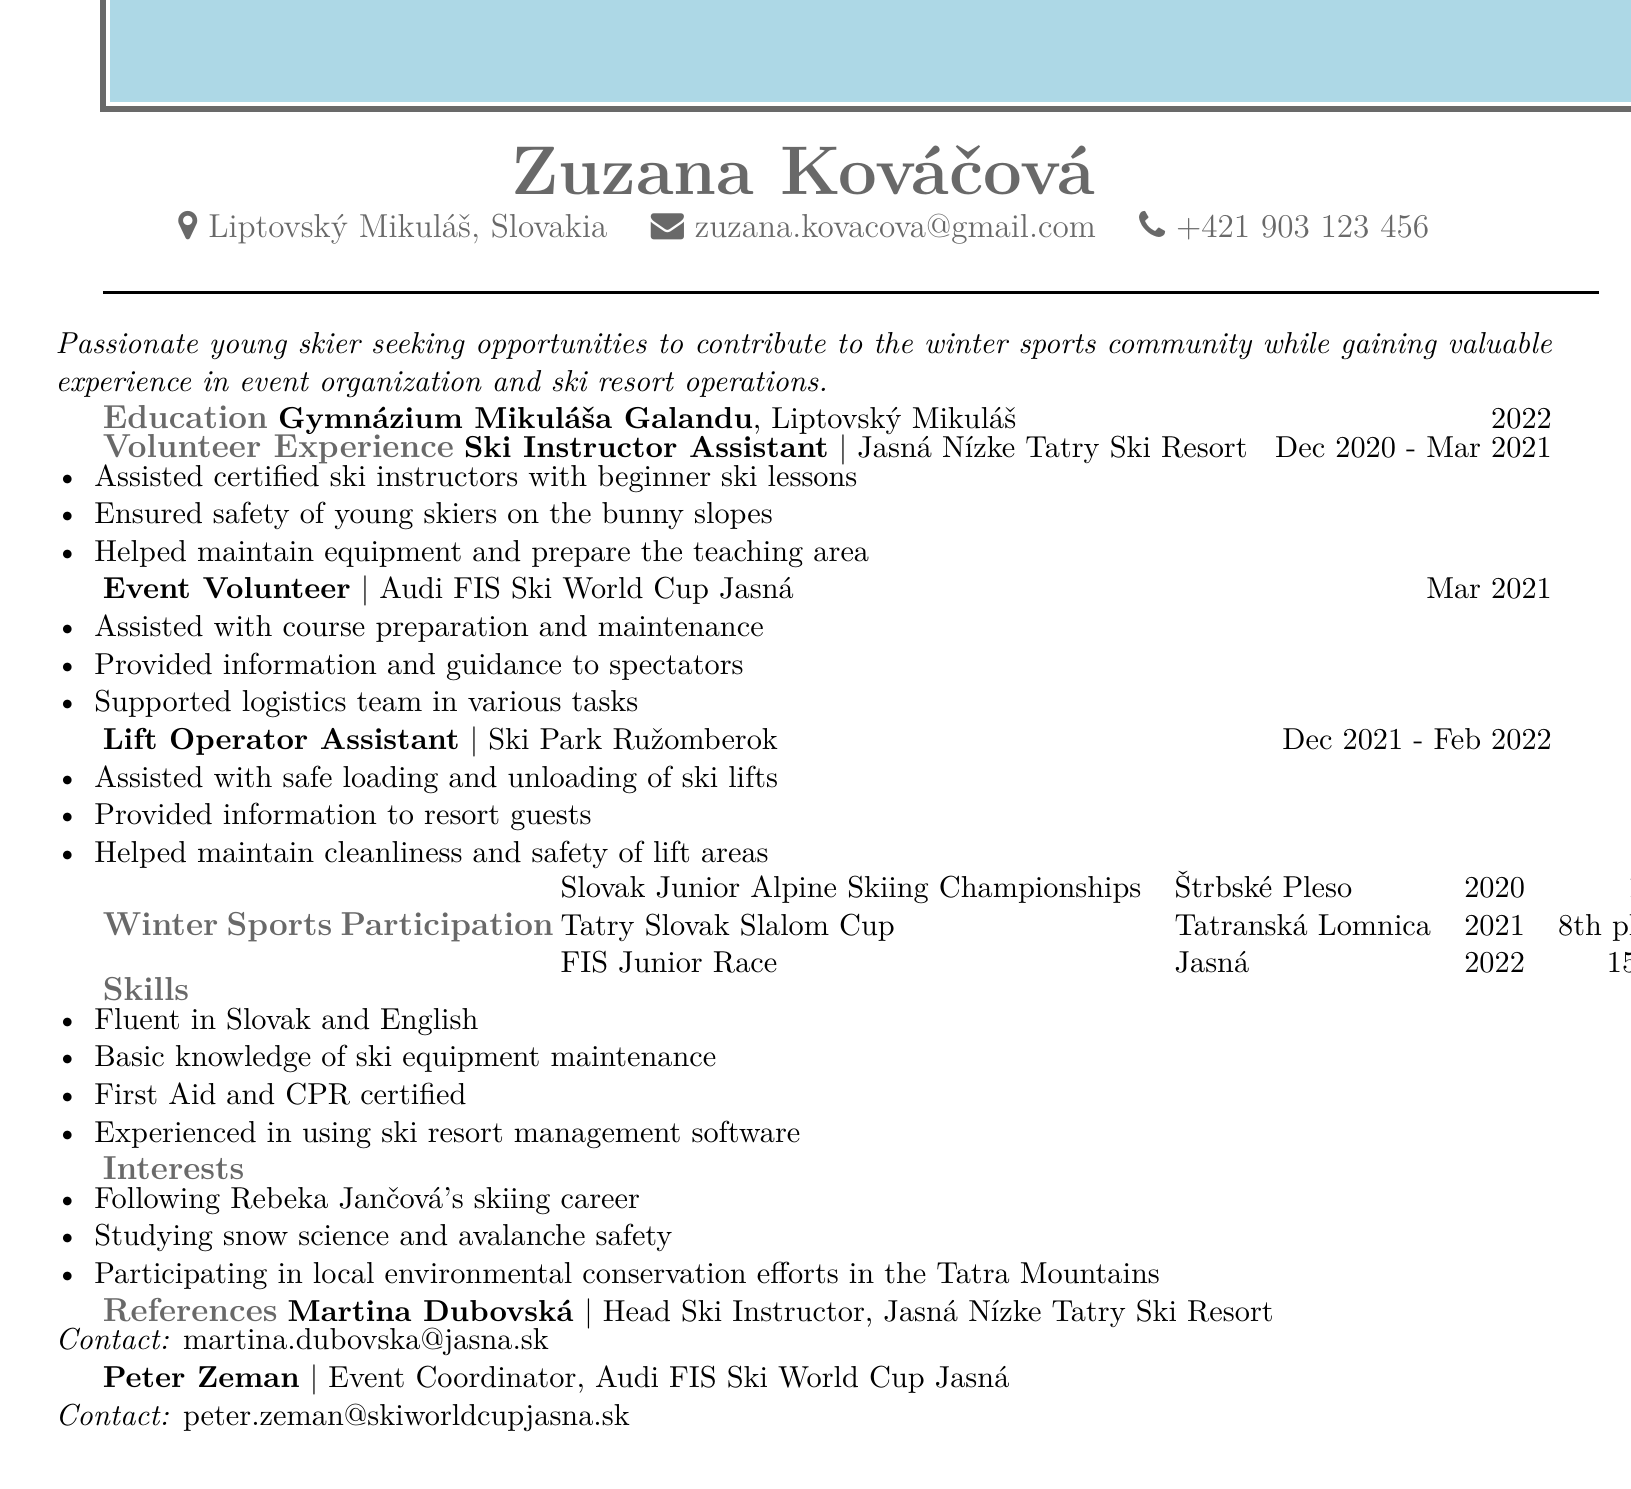What is Zuzana Kováčová's age? The age is directly stated in the personal information section of the document as 19.
Answer: 19 Where did Zuzana volunteer as a Ski Instructor Assistant? The document states she volunteered at Jasná Nízke Tatry Ski Resort.
Answer: Jasná Nízke Tatry Ski Resort What year did Zuzana graduate from high school? The graduation year is mentioned in the education section as 2022.
Answer: 2022 What is Zuzana's position during the Audi FIS Ski World Cup? The document lists her position as Event Volunteer during this event.
Answer: Event Volunteer What place did Zuzana achieve in the Tatry Slovak Slalom Cup? The result from this event is specifically mentioned in the document as 8th place.
Answer: 8th place What skills does Zuzana possess related to first aid? The document mentions that she is First Aid and CPR certified.
Answer: First Aid and CPR certified What is one of Zuzana's interests? The document lists her interest in following Rebeka Jančová's skiing career.
Answer: Following Rebeka Jančová's skiing career How many events does Zuzana list under winter sports participation? The document details three events she participated in.
Answer: Three Who is Zuzana's reference in the Jasná Nízke Tatry Ski Resort? The document lists Martina Dubovská as her reference from this organization.
Answer: Martina Dubovská 